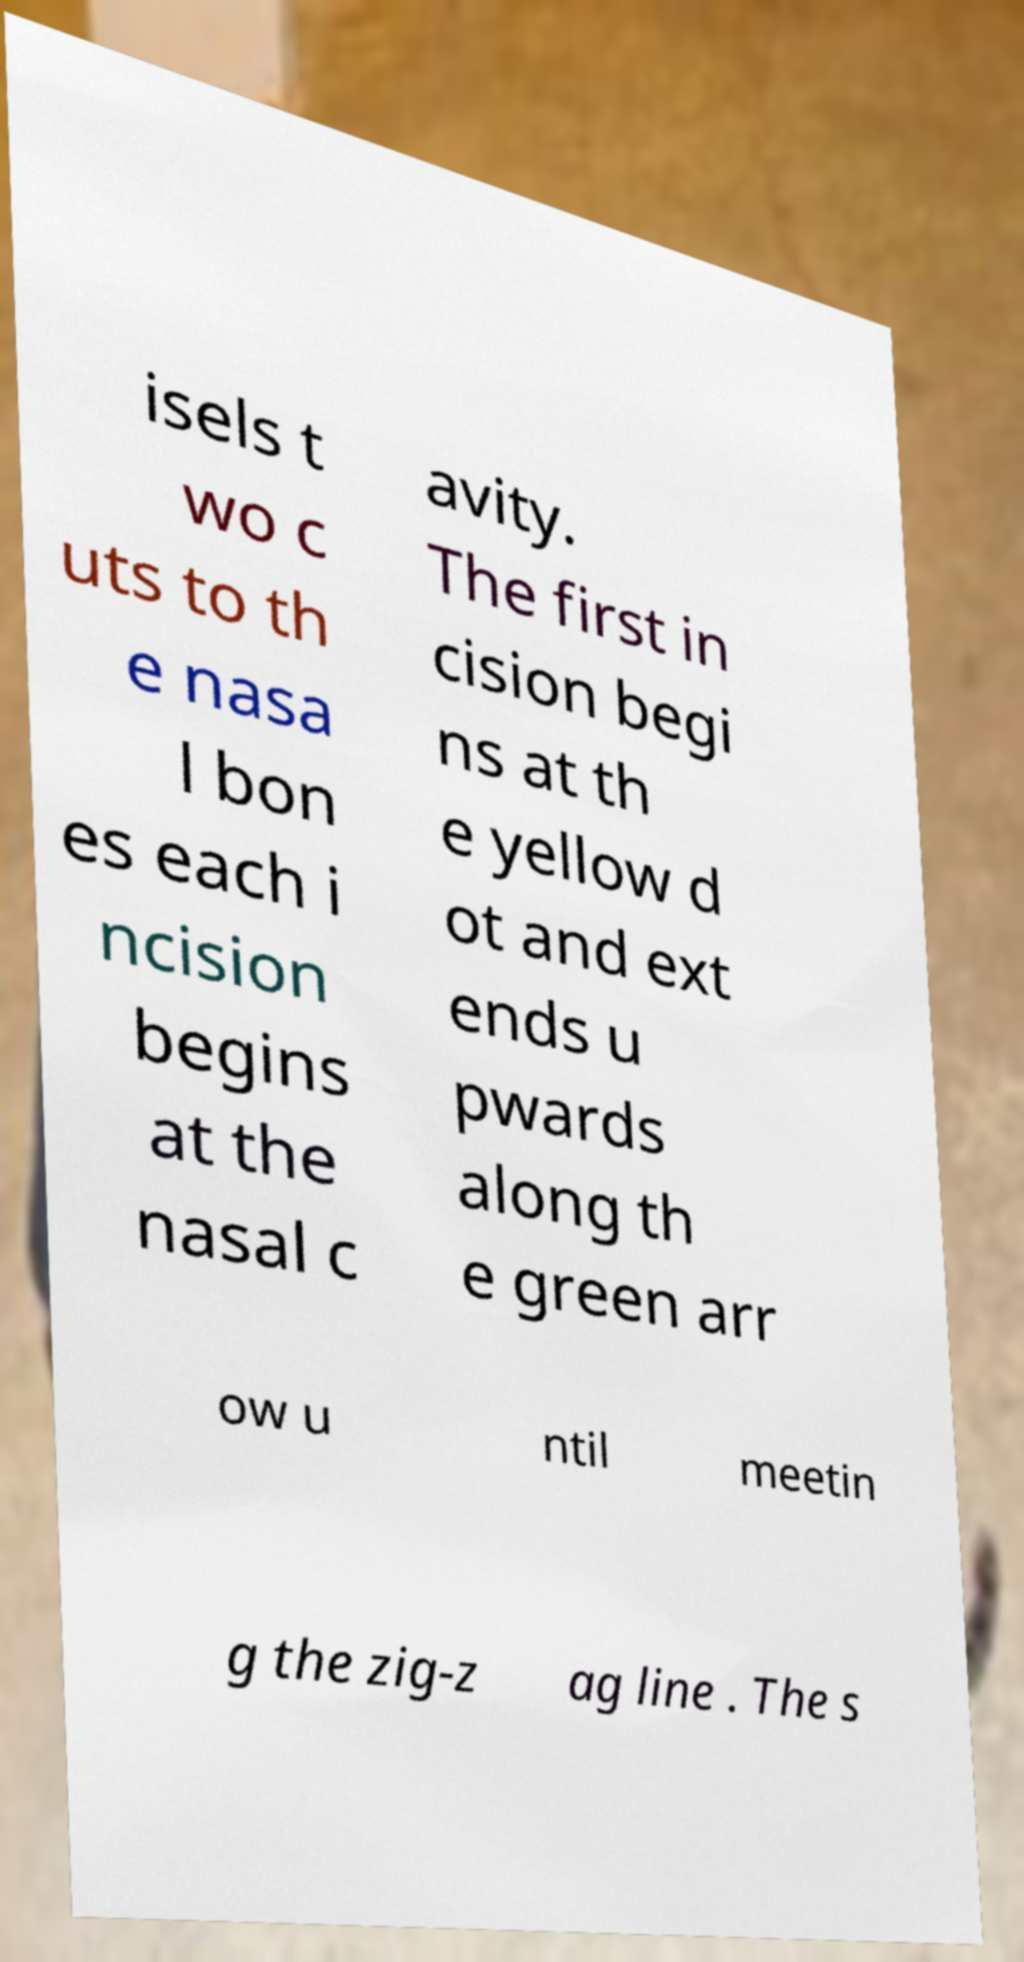Could you extract and type out the text from this image? isels t wo c uts to th e nasa l bon es each i ncision begins at the nasal c avity. The first in cision begi ns at th e yellow d ot and ext ends u pwards along th e green arr ow u ntil meetin g the zig-z ag line . The s 